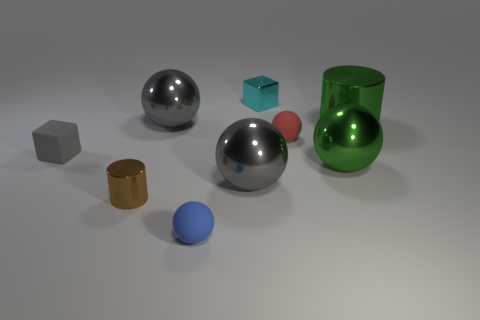Add 1 brown shiny cylinders. How many objects exist? 10 Subtract all matte balls. How many balls are left? 3 Subtract all red cubes. How many gray balls are left? 2 Subtract all blocks. How many objects are left? 7 Subtract 2 spheres. How many spheres are left? 3 Subtract all brown cubes. Subtract all gray spheres. How many cubes are left? 2 Subtract all small green blocks. Subtract all blue balls. How many objects are left? 8 Add 5 small shiny things. How many small shiny things are left? 7 Add 5 blue objects. How many blue objects exist? 6 Subtract all gray blocks. How many blocks are left? 1 